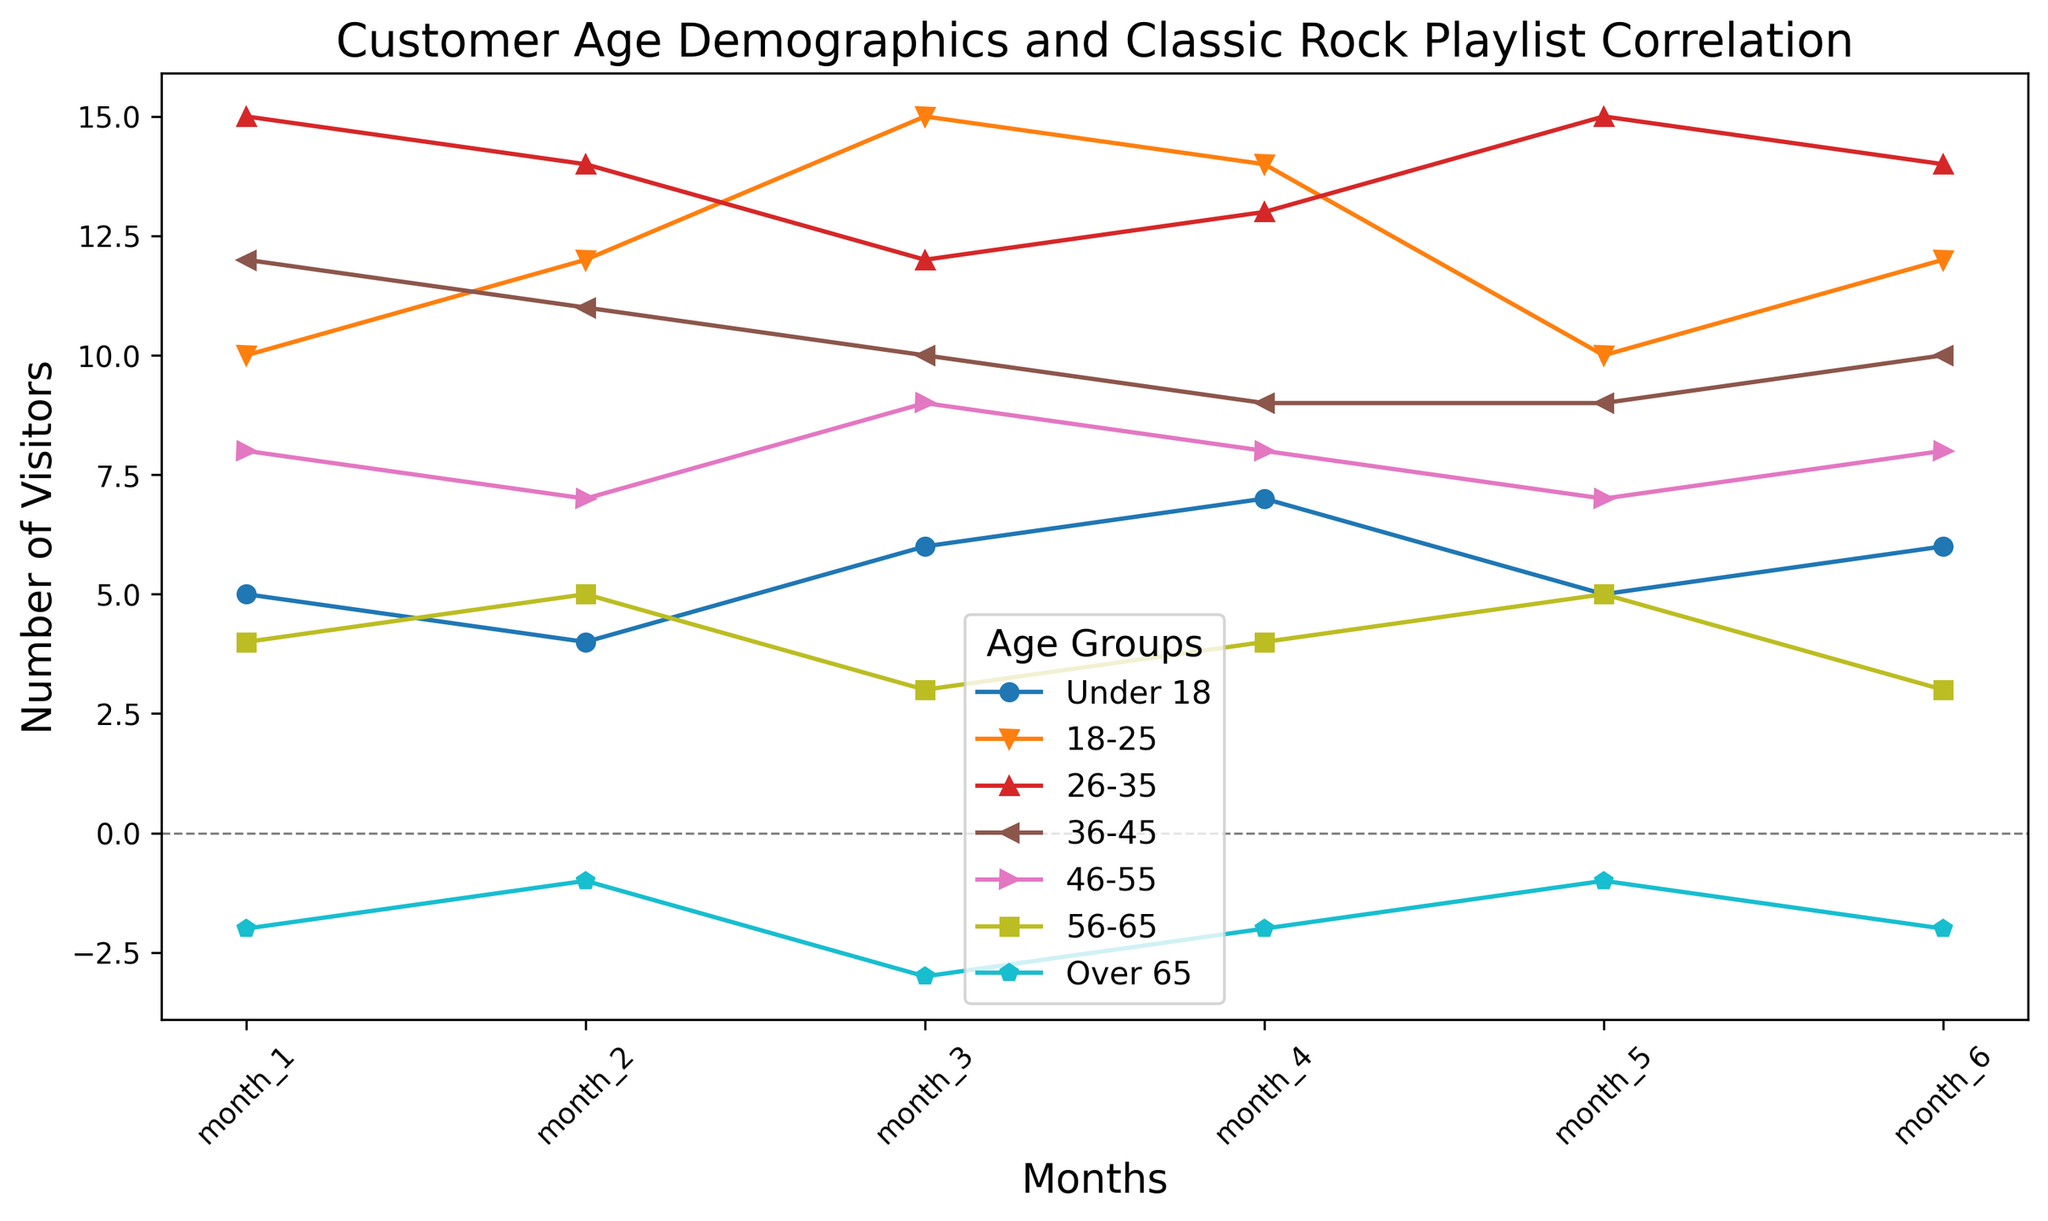What age group showed an increase in visitor numbers from month 1 to month 6? To find this, look at the values for each age group in month 1 and compare them to month 6. Only age groups with higher numbers in month 6 than in month 1 qualify.
Answer: Under 18, 18-25, 46-55 Which age group had the highest number of visitors in month 3? Examine the data for month 3 and compare the visitor numbers across all age groups to identify the one with the highest value.
Answer: 18-25 What is the average number of visitors for the 26-35 age group over the six months? Sum the visitor numbers for 26-35 from month 1 to month 6 and divide by the number of months (6). (15+14+12+13+15+14) / 6 = 83 / 6 ≈ 13.83
Answer: 13.83 Which age group consistently had negative visitor numbers? Look for the age group where all values from month 1 to month 6 are negative.
Answer: Over 65 How much did visitor numbers change for the 36-45 age group from month 2 to month 5? Subtract the value in month 5 from the value in month 2 for the 36-45 age group. 11 - 9 = 2
Answer: 2 During which month did the 18-25 age group experience the worst month compared to other months for that same age group? Identify the month with the lowest number of visitors specifically for the 18-25 age group.
Answer: Month 1 and Month 5 (both 10 visitors) Which age group had exactly 8 visitors in any month? Check the visitor numbers across all age groups and months to find any that had exactly 8 visitors.
Answer: 46-55 What is the total number of visitors in month 4 across all age groups? Sum the visitor numbers from all age groups for month 4. 7+14+13+9+8+4-2 = 53
Answer: 53 